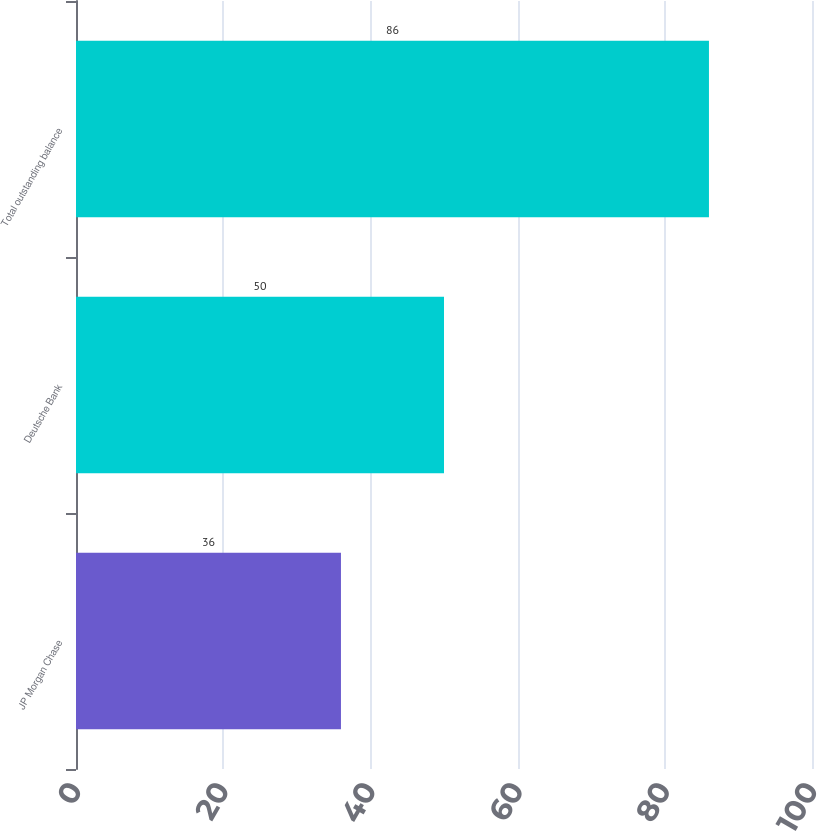Convert chart to OTSL. <chart><loc_0><loc_0><loc_500><loc_500><bar_chart><fcel>JP Morgan Chase<fcel>Deutsche Bank<fcel>Total outstanding balance<nl><fcel>36<fcel>50<fcel>86<nl></chart> 